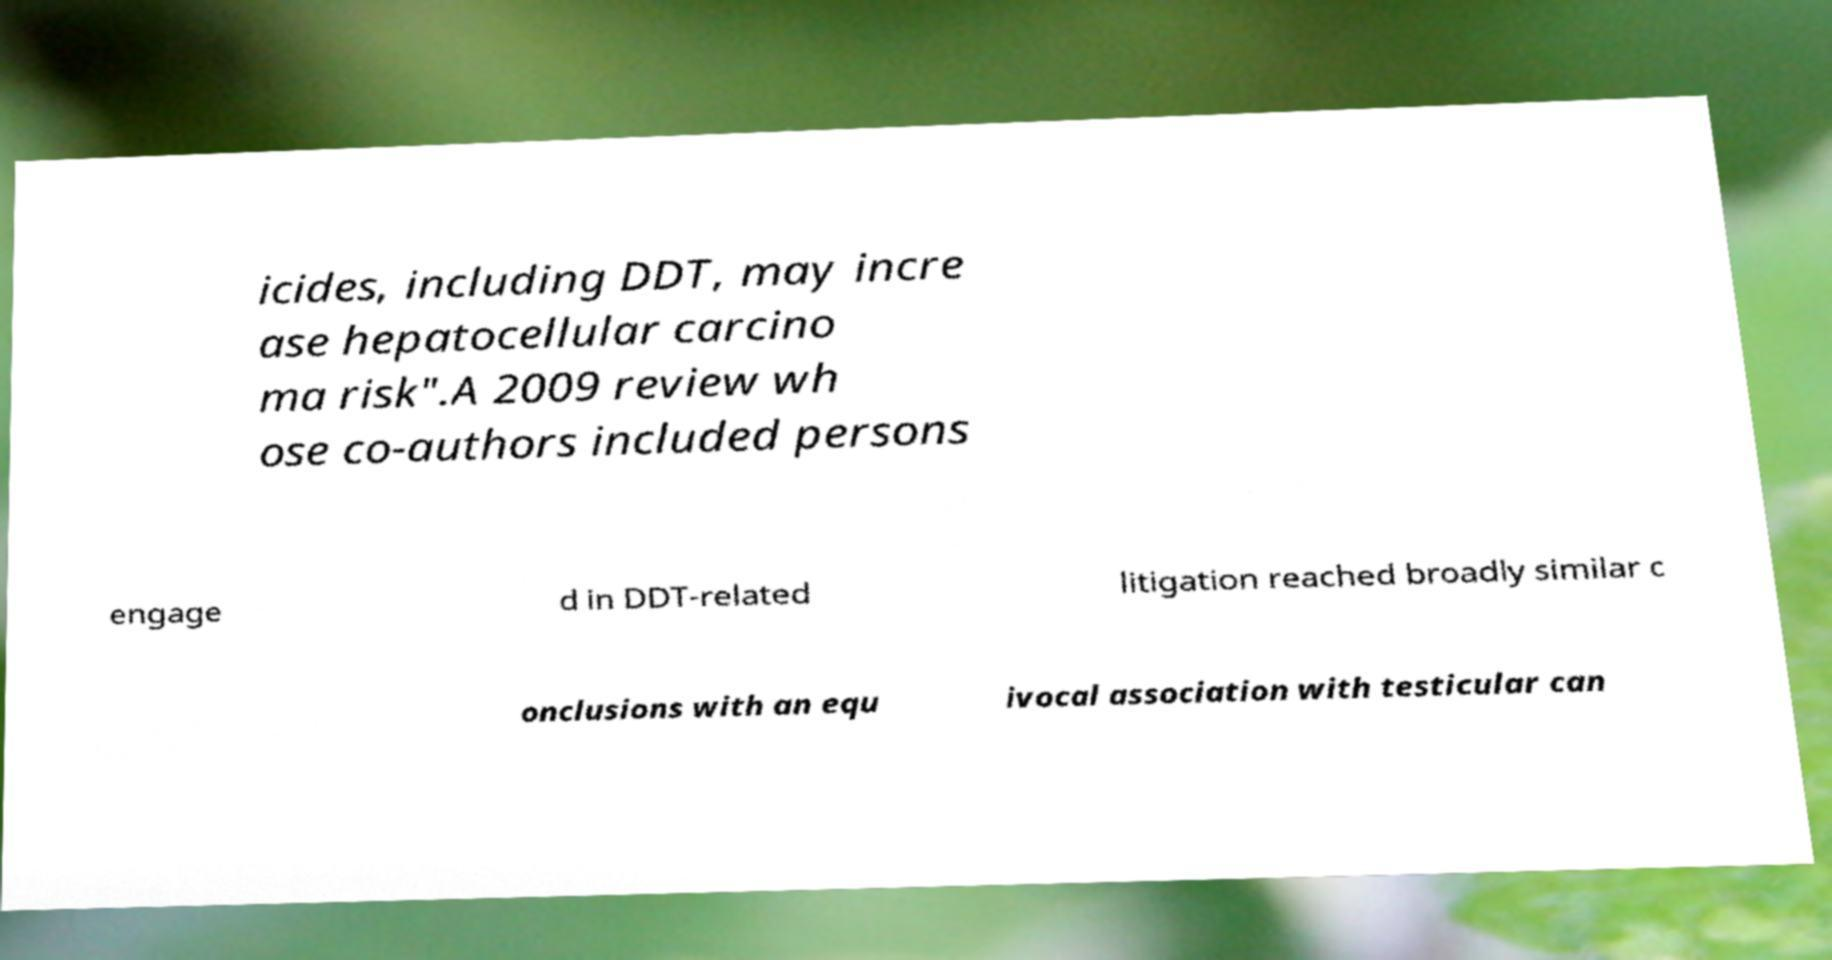Can you read and provide the text displayed in the image?This photo seems to have some interesting text. Can you extract and type it out for me? icides, including DDT, may incre ase hepatocellular carcino ma risk".A 2009 review wh ose co-authors included persons engage d in DDT-related litigation reached broadly similar c onclusions with an equ ivocal association with testicular can 